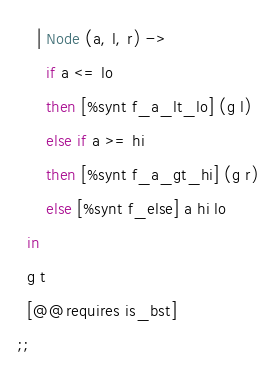Convert code to text. <code><loc_0><loc_0><loc_500><loc_500><_OCaml_>    | Node (a, l, r) ->
      if a <= lo
      then [%synt f_a_lt_lo] (g l)
      else if a >= hi
      then [%synt f_a_gt_hi] (g r)
      else [%synt f_else] a hi lo
  in
  g t
  [@@requires is_bst]
;;
</code> 